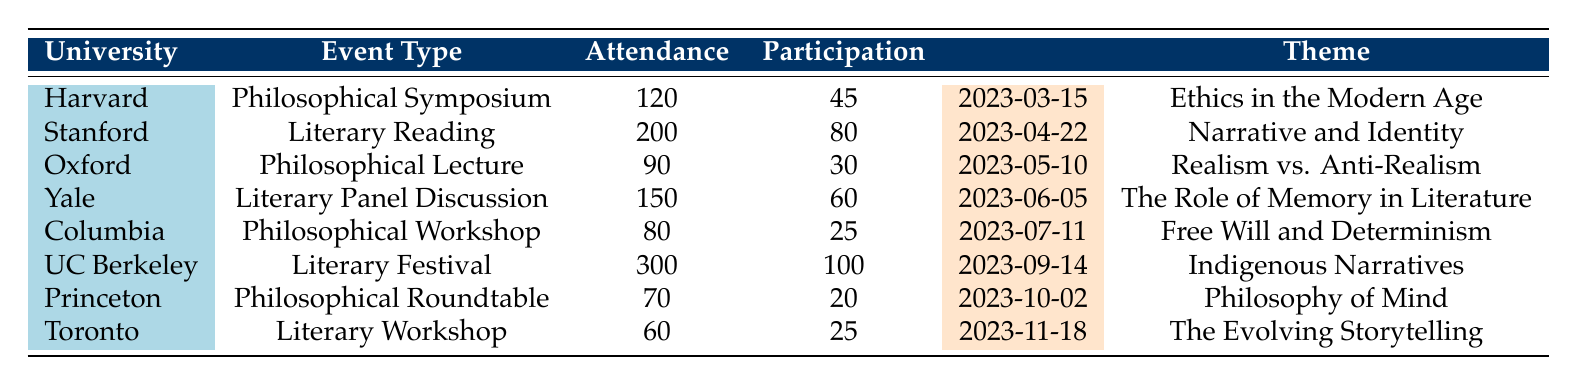What university hosted the "Literary Festival"? The table lists the events along with their respective universities. The "Literary Festival" is recorded under the "University of California, Berkeley" column.
Answer: University of California, Berkeley What was the attendance for the "Philosophical Roundtable"? To find this, we look for the row corresponding to "Philosophical Roundtable," which is hosted by Princeton University. The attendance listed there is 70.
Answer: 70 Which event had the highest participation? By reviewing the participation column, we see that the "Literary Festival" held at University of California, Berkeley has the highest participation number, with 100 participants.
Answer: 100 What is the total attendance for all philosophical events? We sum the attendance values for "Philosophical Symposium," "Philosophical Lecture," "Philosophical Workshop," and "Philosophical Roundtable." This results in: 120 + 90 + 80 + 70 = 360.
Answer: 360 Did the "Literary Reading" have more participation than the "Philosophical Workshop"? The "Literary Reading" has a participation of 80 while the "Philosophical Workshop" has a participation of only 25. Therefore, the "Literary Reading" did indeed have more participation.
Answer: Yes Which theme had the lowest attendance figure, and what was that number? The table shows various events and their attendance figures. The event with the lowest attendance is the "Literary Workshop" at the University of Toronto, with an attendance of 60.
Answer: The Evolving Storytelling, 60 How many more attendees were there at the "Literary Festival" compared to the "Literary Reading"? The "Literary Festival" had an attendance of 300, and the "Literary Reading" had an attendance of 200. Therefore, the difference is 300 - 200 = 100.
Answer: 100 What proportion of attendees participated in the "Philosophical Lecture"? For the "Philosophical Lecture," the attendance was 90 and the participation was 30. To calculate the proportion, we divide participation by attendance: 30/90 = 1/3 or approximately 33.33%.
Answer: 33.33% Which university had the most notable speakers listed, and how many speakers does that event feature? To find this, we count the notable speakers for each event listed. The "Philosophical Symposium" at Harvard University has 2 notable speakers, and the same is true for the "Literary Reading" at Stanford University and "Literary Festival" at UC Berkeley, which all have 2. However, the "Literary Festival" has the most notable authors; hence we can assess involvement through various metrics.
Answer: Literary Festival, 2 